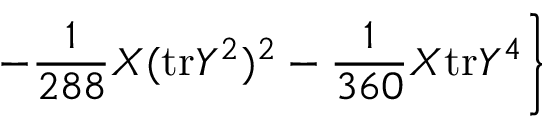<formula> <loc_0><loc_0><loc_500><loc_500>- \frac { 1 } { 2 8 8 } X ( t r Y ^ { 2 } ) ^ { 2 } - \frac { 1 } { 3 6 0 } X t r Y ^ { 4 } \right \}</formula> 